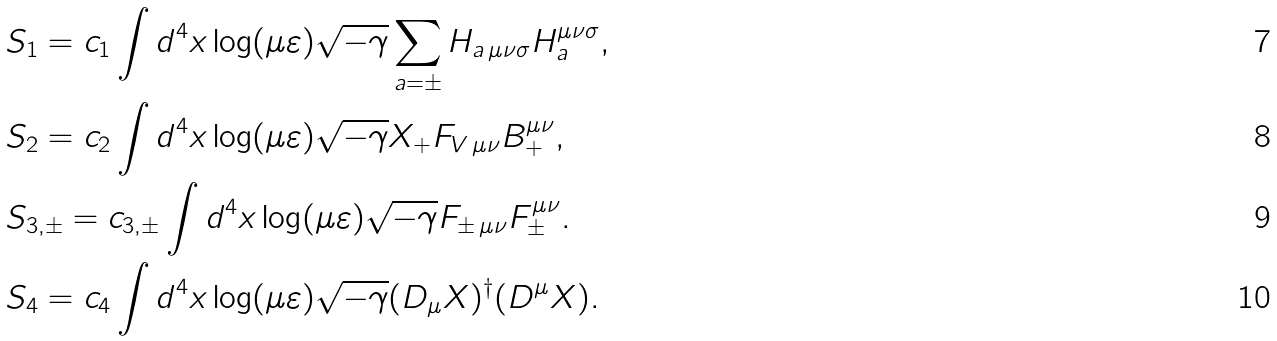Convert formula to latex. <formula><loc_0><loc_0><loc_500><loc_500>& S _ { 1 } = c _ { 1 } \int d ^ { 4 } x \log ( \mu \varepsilon ) \sqrt { - \gamma } \sum _ { a = \pm } H _ { a \, \mu \nu \sigma } H _ { a } ^ { \mu \nu \sigma } , \\ & S _ { 2 } = c _ { 2 } \int d ^ { 4 } x \log ( \mu \varepsilon ) \sqrt { - \gamma } X _ { + } F _ { V \, \mu \nu } B _ { + } ^ { \mu \nu } , \\ & S _ { 3 , \pm } = c _ { 3 , \pm } \int d ^ { 4 } x \log ( \mu \varepsilon ) \sqrt { - \gamma } F _ { \pm \, \mu \nu } F _ { \pm } ^ { \mu \nu } . \\ & S _ { 4 } = c _ { 4 } \int d ^ { 4 } x \log ( \mu \varepsilon ) \sqrt { - \gamma } ( D _ { \mu } X ) ^ { \dagger } ( D ^ { \mu } X ) .</formula> 